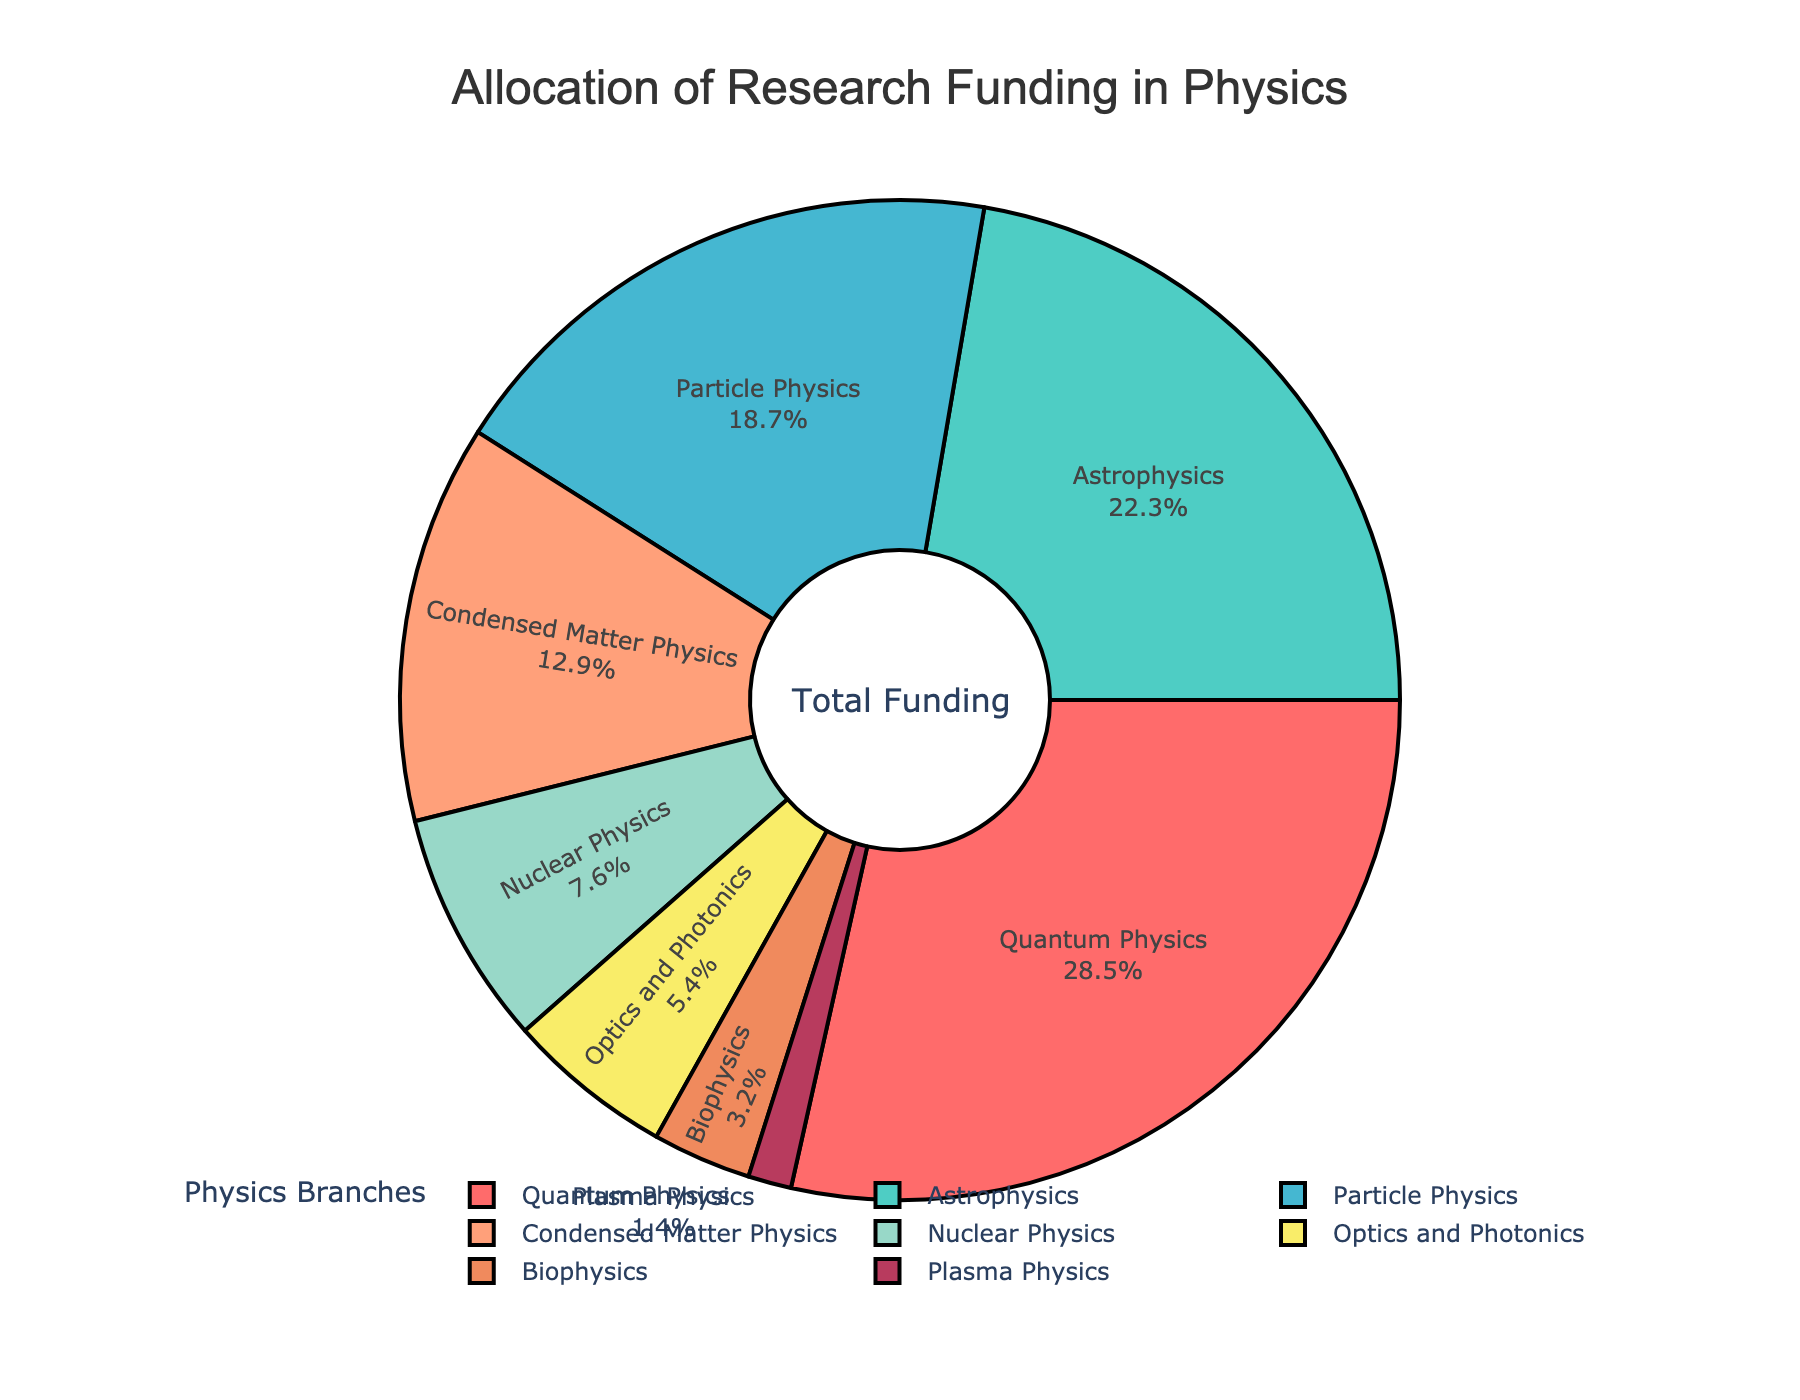What is the percentage of funding allocated to Astrophysics? The pie chart clearly shows the funding percentage for each branch. Astrophysics has a label with a percentage value next to it.
Answer: 22.3% Which branch received the highest amount of funding? By observing the slices of the pie chart, we can see that the largest slice corresponds to Quantum Physics.
Answer: Quantum Physics What is the combined percentage of funding allocated to Nuclear Physics and Plasma Physics? The chart provides the percentage for each branch. Sum the percentages for Nuclear Physics (7.6%) and Plasma Physics (1.4%). 7.6% + 1.4% = 9.0%
Answer: 9.0% How does the funding for Optics and Photonics compare to that for Biophysics? Look at the pie chart segments for Optics and Photonics (5.4%) and Biophysics (3.2%) and compare their sizes.
Answer: Optics and Photonics receives a higher percentage of funding than Biophysics Which branch received the least funding? By examining the smallest slice of the pie chart, we can identify that Plasma Physics has the smallest segment.
Answer: Plasma Physics What is the difference in funding percentage between Quantum Physics and Particle Physics? Find the slices for Quantum Physics (28.5%) and Particle Physics (18.7%) and calculate the difference. 28.5% - 18.7% = 9.8%
Answer: 9.8% What percentage of funding is allocated to branches other than Quantum Physics, Astrophysics, and Particle Physics? Add the percentages for Quantum Physics (28.5%), Astrophysics (22.3%), and Particle Physics (18.7%), then subtract their sum from 100%. 28.5% + 22.3% + 18.7% = 69.5%. 100% - 69.5% = 30.5%
Answer: 30.5% What is the average funding percentage for Condensed Matter Physics, Optics and Photonics, and Biophysics? Sum the percentages for Condensed Matter Physics (12.9%), Optics and Photonics (5.4%), and Biophysics (3.2%) and then divide by the number of branches (3). (12.9% + 5.4% + 3.2%) / 3 = 21.5% / 3 = 7.17%
Answer: 7.17% 